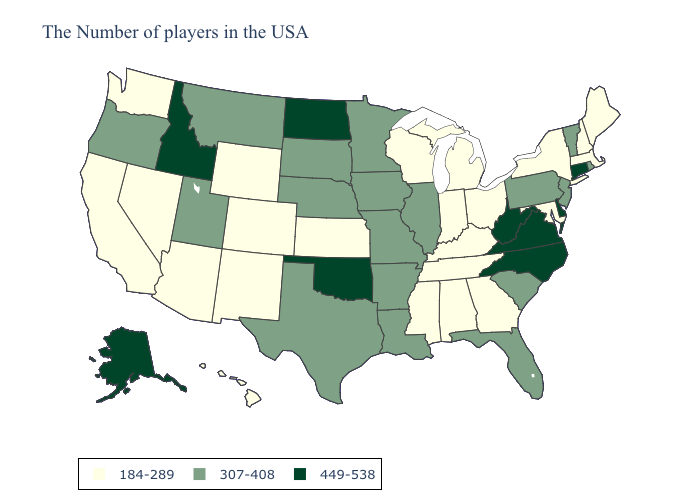What is the value of Michigan?
Answer briefly. 184-289. What is the highest value in states that border Maryland?
Give a very brief answer. 449-538. Does West Virginia have the lowest value in the South?
Write a very short answer. No. Name the states that have a value in the range 449-538?
Concise answer only. Connecticut, Delaware, Virginia, North Carolina, West Virginia, Oklahoma, North Dakota, Idaho, Alaska. What is the lowest value in states that border Louisiana?
Write a very short answer. 184-289. Which states hav the highest value in the Northeast?
Short answer required. Connecticut. What is the value of Massachusetts?
Quick response, please. 184-289. Does Connecticut have the highest value in the Northeast?
Answer briefly. Yes. Name the states that have a value in the range 307-408?
Short answer required. Rhode Island, Vermont, New Jersey, Pennsylvania, South Carolina, Florida, Illinois, Louisiana, Missouri, Arkansas, Minnesota, Iowa, Nebraska, Texas, South Dakota, Utah, Montana, Oregon. Which states have the lowest value in the USA?
Keep it brief. Maine, Massachusetts, New Hampshire, New York, Maryland, Ohio, Georgia, Michigan, Kentucky, Indiana, Alabama, Tennessee, Wisconsin, Mississippi, Kansas, Wyoming, Colorado, New Mexico, Arizona, Nevada, California, Washington, Hawaii. Name the states that have a value in the range 307-408?
Give a very brief answer. Rhode Island, Vermont, New Jersey, Pennsylvania, South Carolina, Florida, Illinois, Louisiana, Missouri, Arkansas, Minnesota, Iowa, Nebraska, Texas, South Dakota, Utah, Montana, Oregon. Does North Carolina have the highest value in the USA?
Keep it brief. Yes. What is the value of Kansas?
Be succinct. 184-289. Does the first symbol in the legend represent the smallest category?
Short answer required. Yes. 